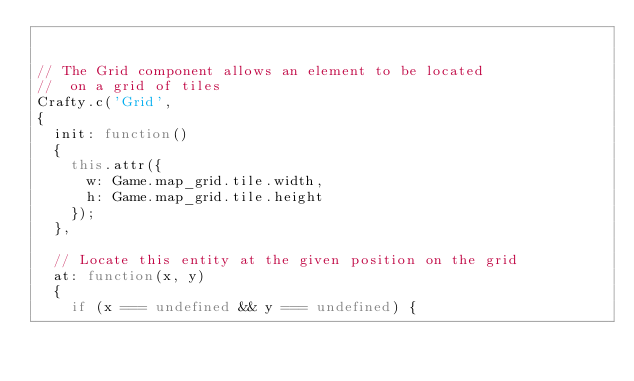<code> <loc_0><loc_0><loc_500><loc_500><_JavaScript_>
 
// The Grid component allows an element to be located
//  on a grid of tiles
Crafty.c('Grid', 
{
  init: function() 
  {
    this.attr({
      w: Game.map_grid.tile.width,
      h: Game.map_grid.tile.height
    });
  },

  // Locate this entity at the given position on the grid
  at: function(x, y) 
  {
    if (x === undefined && y === undefined) {</code> 